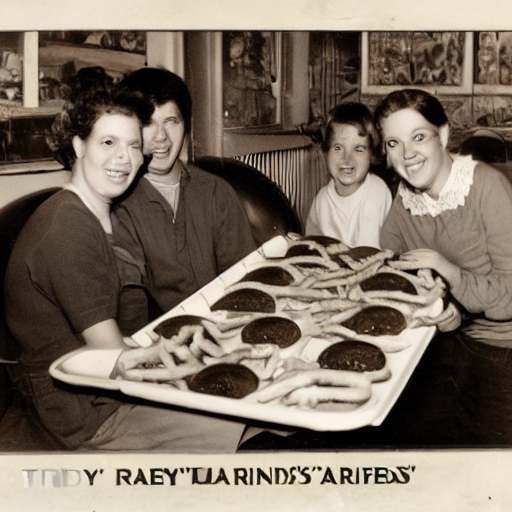Can you clearly see the people and text on the poster? Yes, the image displays four individuals smiling for the camera while presenting a tray of hamburgers and french fries. The text on the poster above them includes names, which appear to be 'TIDY', 'RAEY', 'LARINDS', and 'ARIEFDS', arranged in a whimsical manner suggestive of nicknames or thematic amusement. The text and people are discernible, conveying a lively, nostalgic scene likely from a diner or a gathering. 